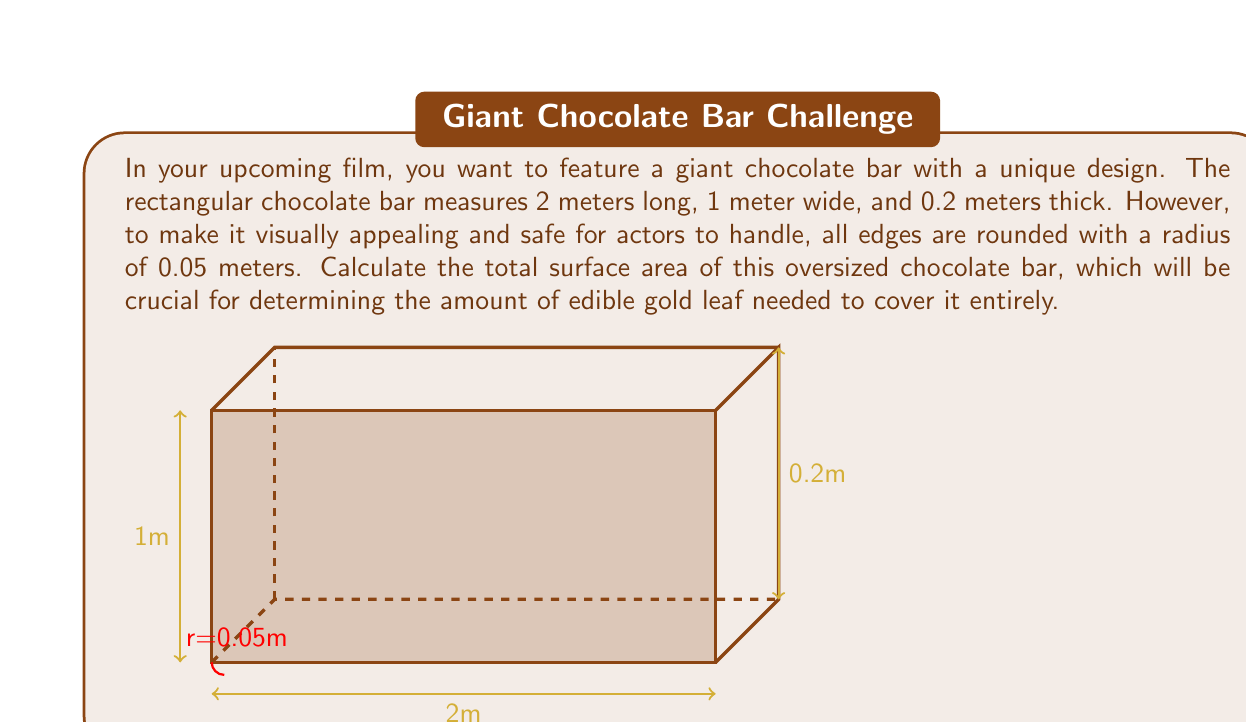Could you help me with this problem? Let's break this down step-by-step:

1) First, let's calculate the surface area without considering the rounded edges:
   Top and bottom: $2 * (2 * 1) = 4$ m²
   Front and back: $2 * (2 * 0.2) = 0.8$ m²
   Left and right: $2 * (1 * 0.2) = 0.4$ m²
   Total: $4 + 0.8 + 0.4 = 5.2$ m²

2) Now, we need to subtract the area lost due to rounding:
   12 edges, each 0.05m in radius and length of either 2m, 1m, or 0.2m
   Area lost per edge: $\pi r^2 = \pi * 0.05^2 \approx 0.007854$ m²
   Total area lost: $12 * 0.007854 = 0.094248$ m²

3) We also need to add the surface area of the rounded parts:
   For long edges (2m): $2 * (2 * \pi * 0.05 * 2) = 1.256637$ m²
   For medium edges (1m): $4 * (2 * \pi * 0.05 * 1) = 1.256637$ m²
   For short edges (0.2m): $6 * (2 * \pi * 0.05 * 0.2) = 0.376991$ m²

4) Summing it all up:
   Total surface area = Original surface area - Area lost + Area of rounded parts
   $= 5.2 - 0.094248 + (1.256637 + 1.256637 + 0.376991)$
   $= 5.2 - 0.094248 + 2.890265$
   $= 7.996017$ m²

Therefore, the total surface area of the giant chocolate bar is approximately 7.996017 m².
Answer: $$7.996017 \text{ m}^2$$ 